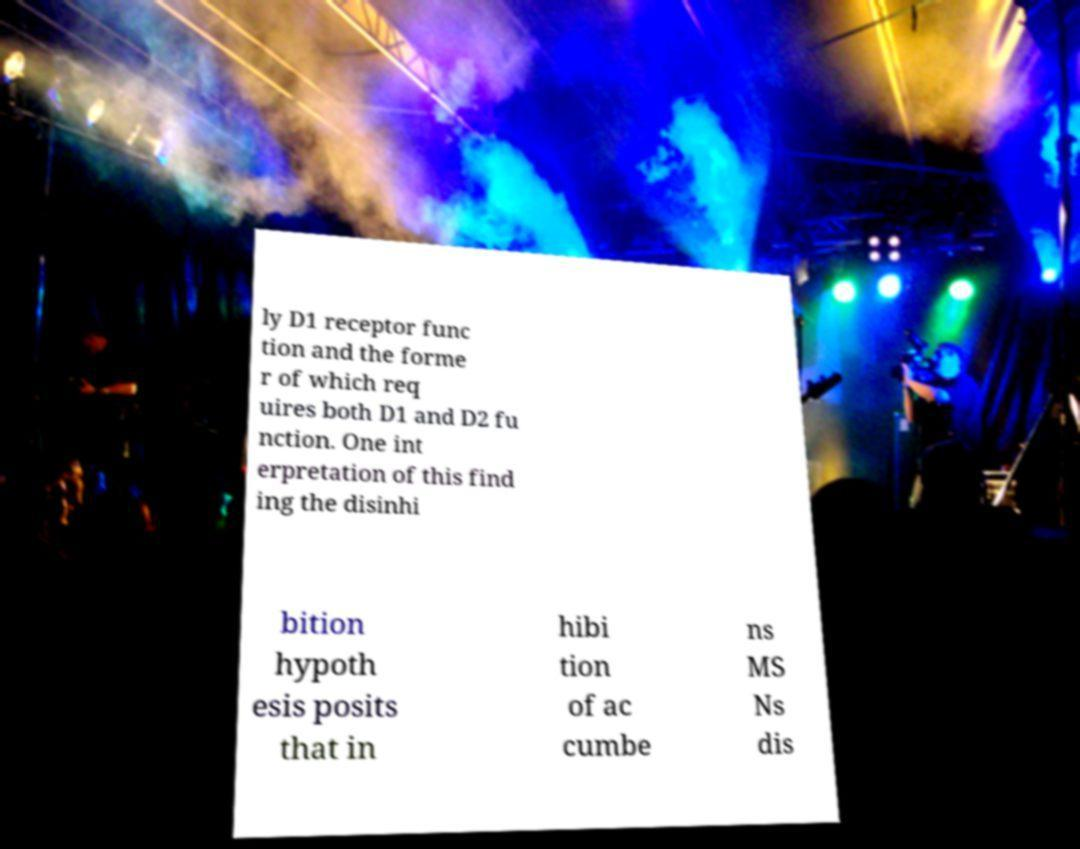Can you read and provide the text displayed in the image?This photo seems to have some interesting text. Can you extract and type it out for me? ly D1 receptor func tion and the forme r of which req uires both D1 and D2 fu nction. One int erpretation of this find ing the disinhi bition hypoth esis posits that in hibi tion of ac cumbe ns MS Ns dis 